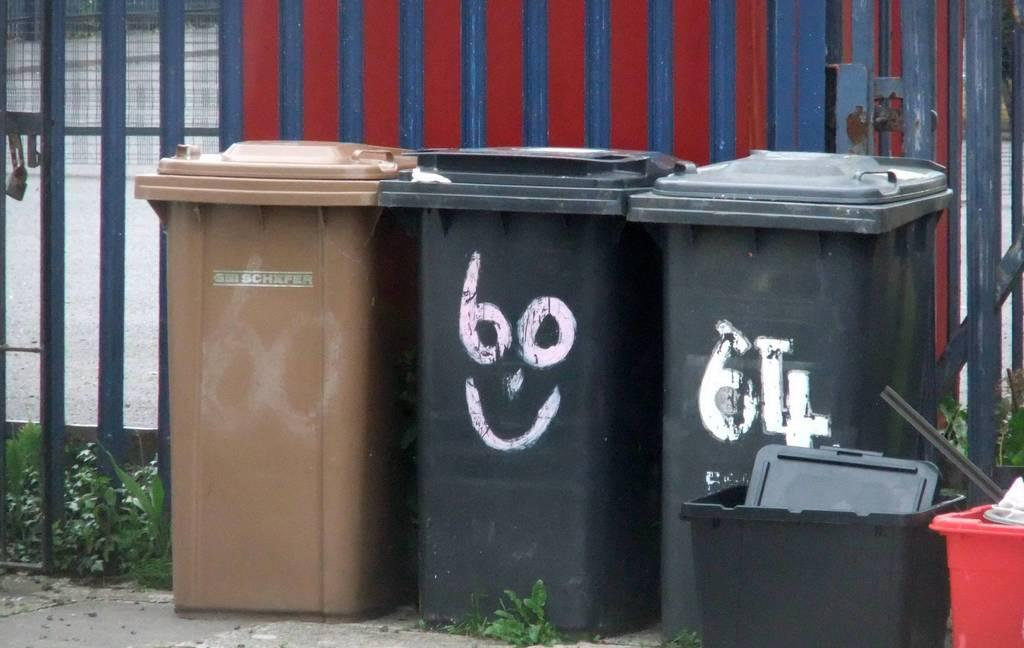<image>
Summarize the visual content of the image. Garbage cans that has text written on them, Bo, and the number 64. 